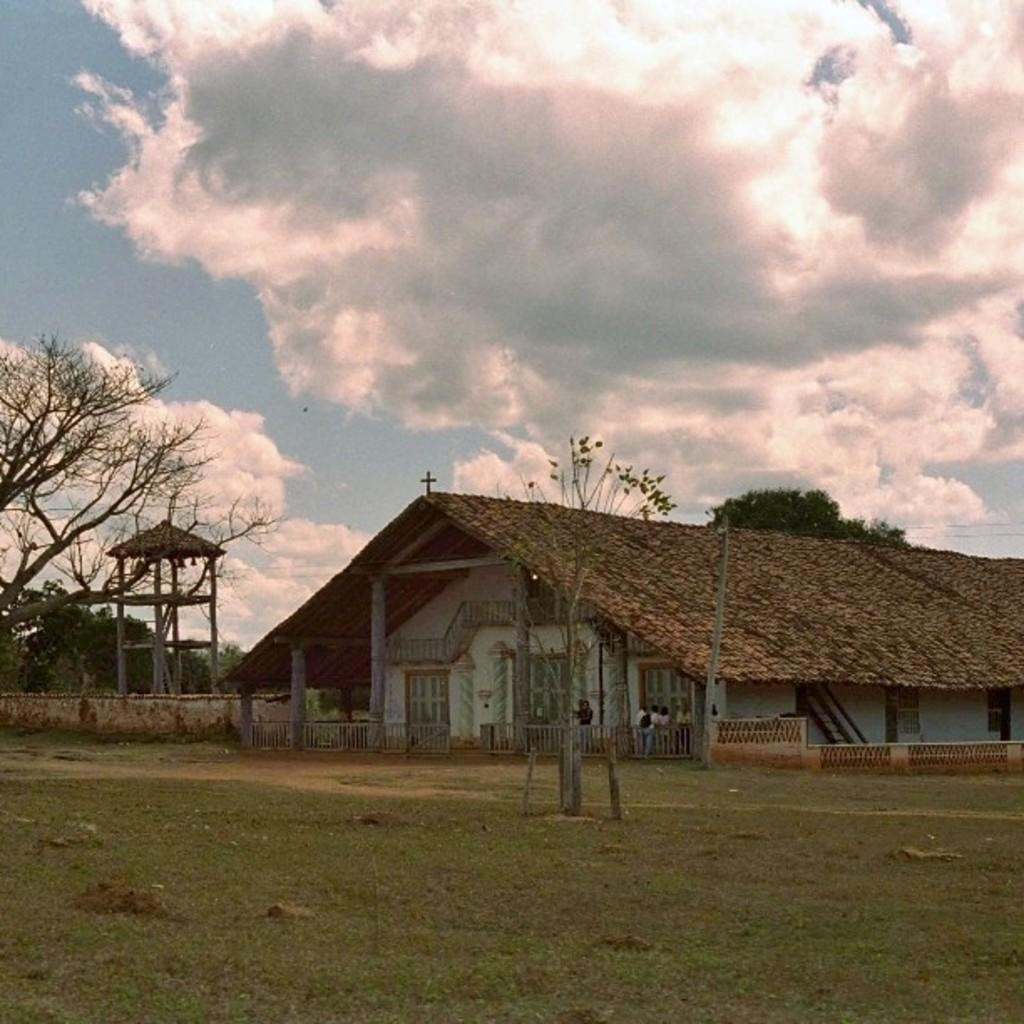What type of structure is visible in the image? There is a house in the image. What can be seen near the house? There is a railing in the image. What type of vegetation is present in the image? There is grass and trees in the image. Are there any living beings in the image? Yes, there are people in the image. What else can be seen in the image besides the house, railing, grass, trees, and people? There are objects in the image. What is the condition of the sky in the image? The sky is visible in the background of the image, and it appears to be cloudy. Can you tell me how many oranges are on the turkey in the image? There is no turkey or orange present in the image. 